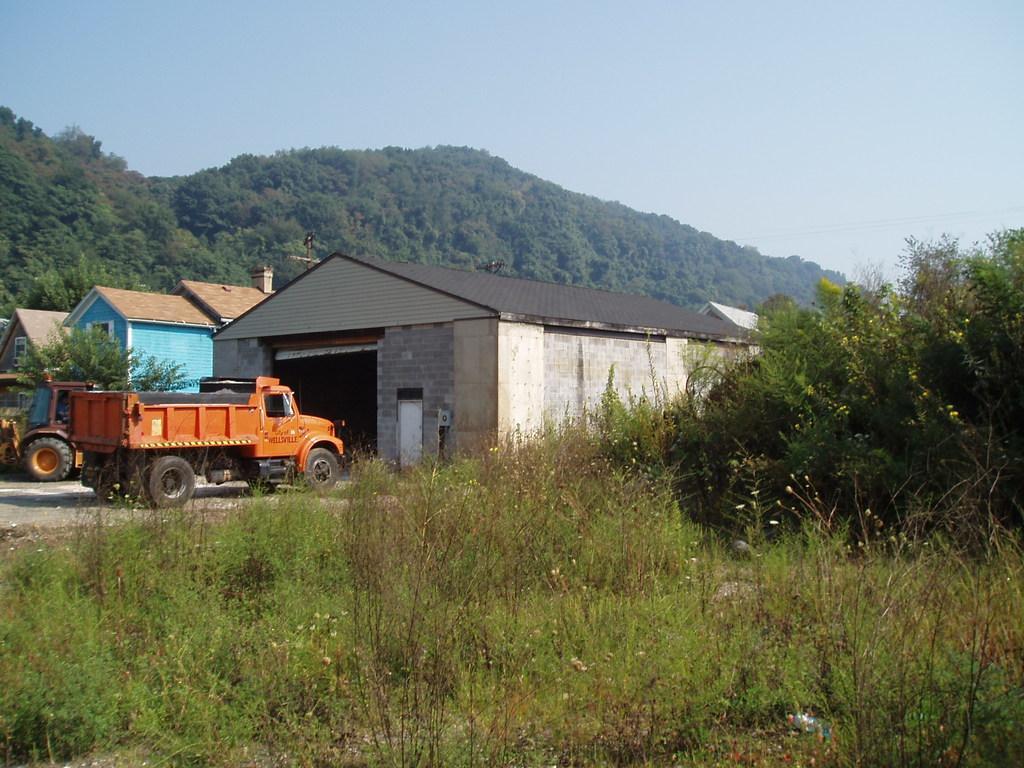How would you summarize this image in a sentence or two? In this picture there is a truck which is parked in front of the shed, beside the shed I can see the house. In the background I can see many trees on the mountains. At the top there is a sky. At the bottom I can see the plants and grass. Beside the truck I can see the JCB. 